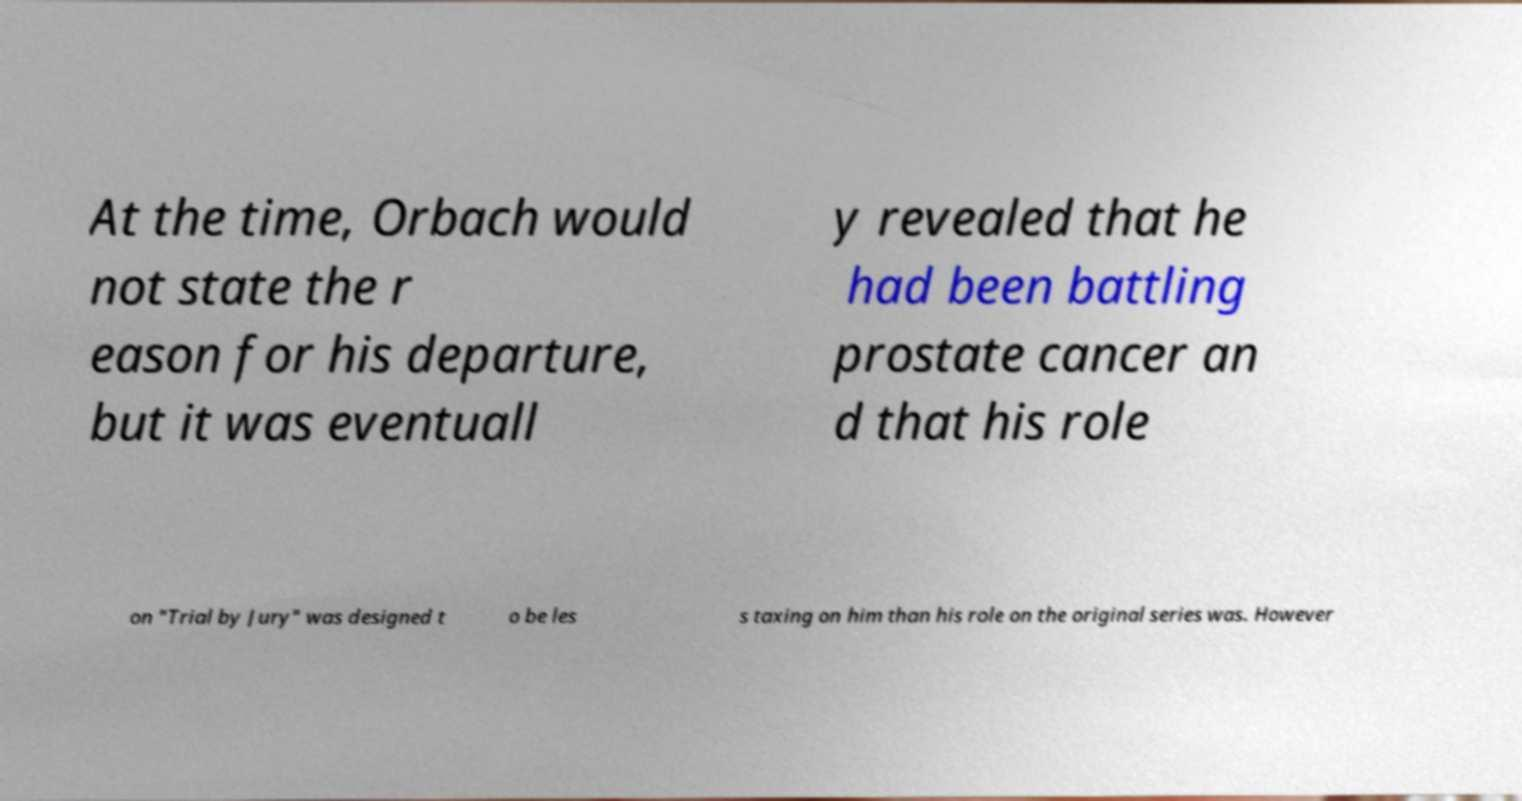Please identify and transcribe the text found in this image. At the time, Orbach would not state the r eason for his departure, but it was eventuall y revealed that he had been battling prostate cancer an d that his role on "Trial by Jury" was designed t o be les s taxing on him than his role on the original series was. However 